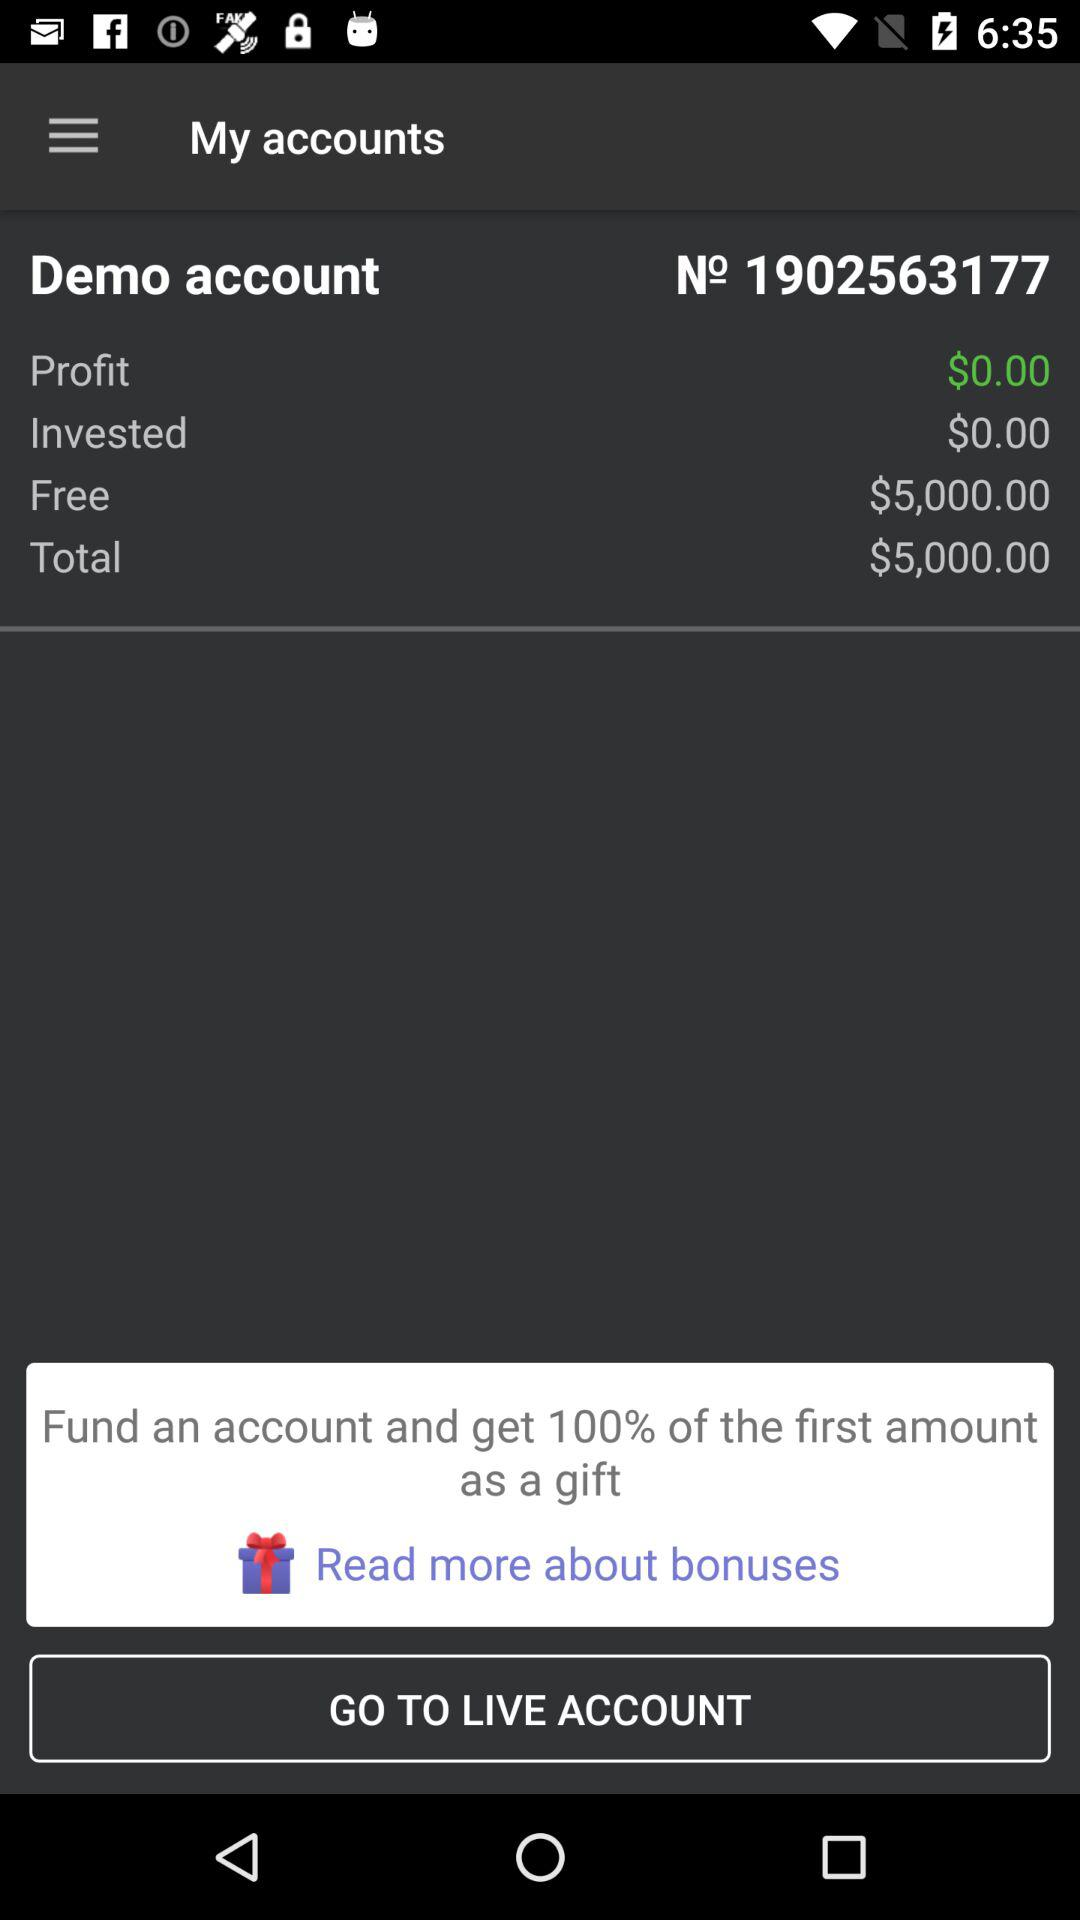How much is the total amount?
Answer the question using a single word or phrase. $5,000.00 